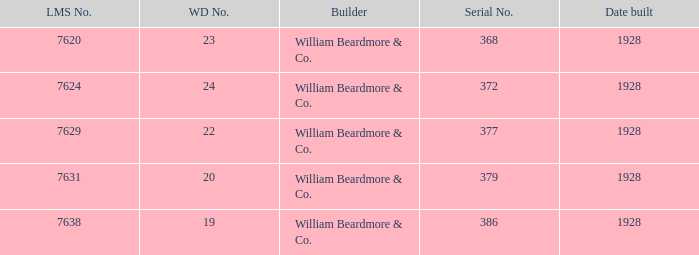Name the builder for serial number being 377 William Beardmore & Co. 